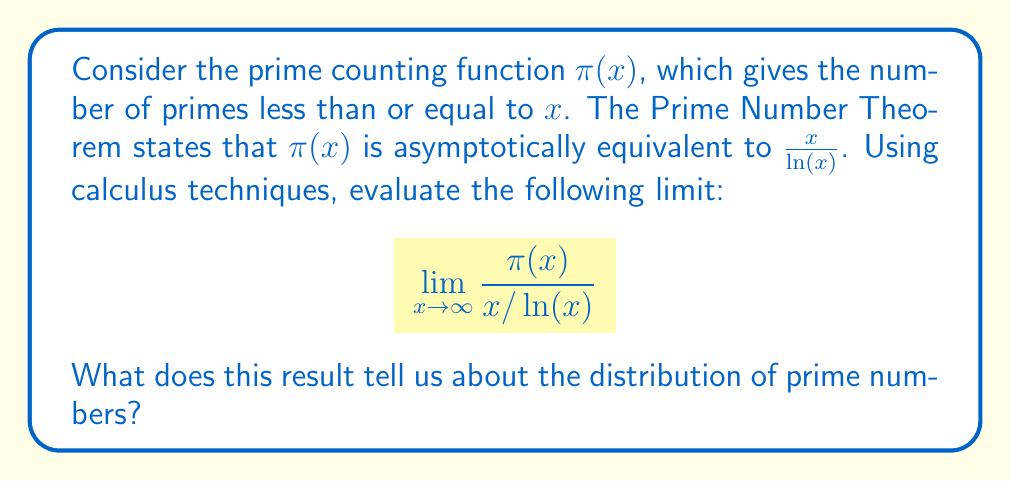Can you answer this question? To analyze this limit, we'll use the Prime Number Theorem and some calculus techniques:

1) The Prime Number Theorem states that:

   $$\pi(x) \sim \frac{x}{\ln(x)}$$

   This means that as $x$ approaches infinity, the ratio of $\pi(x)$ to $\frac{x}{\ln(x)}$ approaches 1.

2) We can express this mathematically as:

   $$\lim_{x \to \infty} \frac{\pi(x)}{x/\ln(x)} = 1$$

3) To understand why this limit is 1, let's consider the definition of asymptotic equivalence:

   Two functions $f(x)$ and $g(x)$ are asymptotically equivalent if:

   $$\lim_{x \to \infty} \frac{f(x)}{g(x)} = 1$$

4) In our case, $f(x) = \pi(x)$ and $g(x) = \frac{x}{\ln(x)}$.

5) This limit tells us that as $x$ gets very large, the prime counting function $\pi(x)$ becomes arbitrarily close to the function $\frac{x}{\ln(x)}$.

6) From a calculus perspective, we can interpret this as saying that the rate of growth of $\pi(x)$ is asymptotically the same as the rate of growth of $\frac{x}{\ln(x)}$.

7) This result is profound because it gives us a relatively simple function $\frac{x}{\ln(x)}$ that approximates the distribution of primes for large $x$.

8) It's worth noting that while $\frac{x}{\ln(x)}$ is a good approximation for $\pi(x)$, it's not exact. There are more precise approximations, such as the logarithmic integral $\text{Li}(x)$, which gives an even better estimate of $\pi(x)$ for large $x$.
Answer: The limit evaluates to 1, i.e., 

$$\lim_{x \to \infty} \frac{\pi(x)}{x/\ln(x)} = 1$$

This result tells us that for very large $x$, the number of primes less than or equal to $x$ is approximately equal to $\frac{x}{\ln(x)}$, providing a key insight into the distribution of prime numbers. 